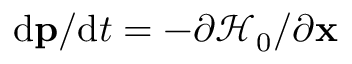Convert formula to latex. <formula><loc_0><loc_0><loc_500><loc_500>d p / d t = - \partial \mathcal { H } _ { 0 } / \partial x</formula> 